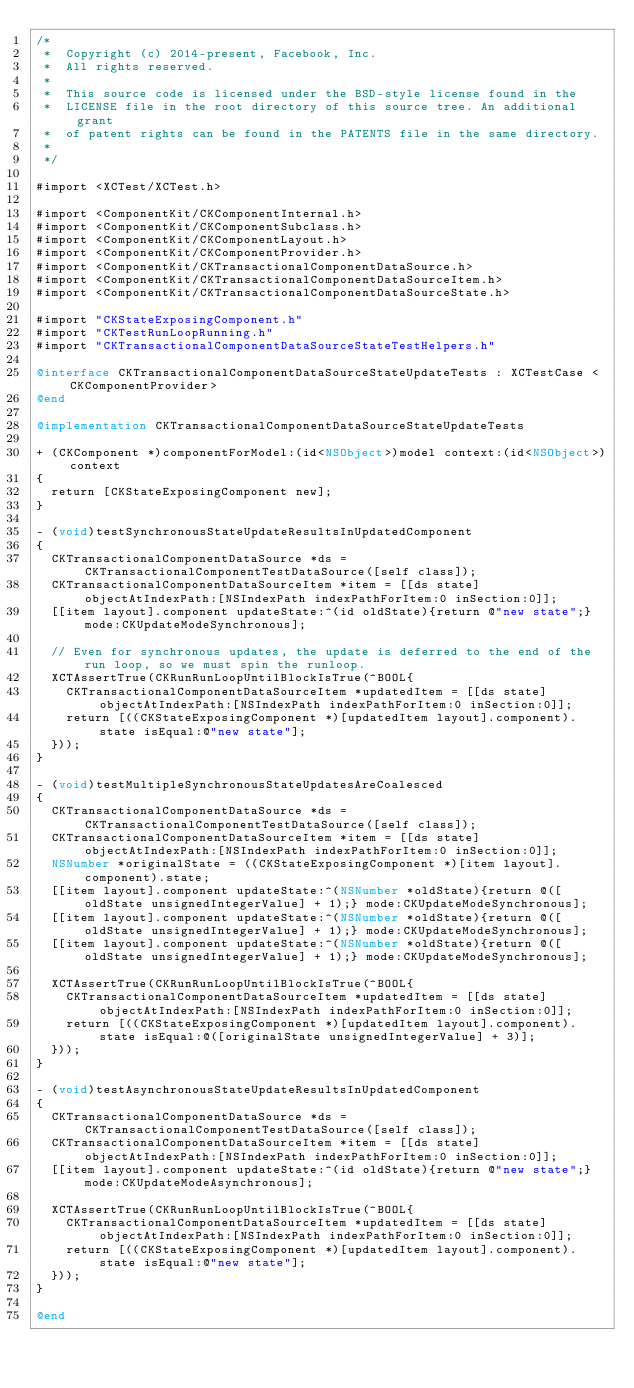<code> <loc_0><loc_0><loc_500><loc_500><_ObjectiveC_>/*
 *  Copyright (c) 2014-present, Facebook, Inc.
 *  All rights reserved.
 *
 *  This source code is licensed under the BSD-style license found in the
 *  LICENSE file in the root directory of this source tree. An additional grant
 *  of patent rights can be found in the PATENTS file in the same directory.
 *
 */

#import <XCTest/XCTest.h>

#import <ComponentKit/CKComponentInternal.h>
#import <ComponentKit/CKComponentSubclass.h>
#import <ComponentKit/CKComponentLayout.h>
#import <ComponentKit/CKComponentProvider.h>
#import <ComponentKit/CKTransactionalComponentDataSource.h>
#import <ComponentKit/CKTransactionalComponentDataSourceItem.h>
#import <ComponentKit/CKTransactionalComponentDataSourceState.h>

#import "CKStateExposingComponent.h"
#import "CKTestRunLoopRunning.h"
#import "CKTransactionalComponentDataSourceStateTestHelpers.h"

@interface CKTransactionalComponentDataSourceStateUpdateTests : XCTestCase <CKComponentProvider>
@end

@implementation CKTransactionalComponentDataSourceStateUpdateTests

+ (CKComponent *)componentForModel:(id<NSObject>)model context:(id<NSObject>)context
{
  return [CKStateExposingComponent new];
}

- (void)testSynchronousStateUpdateResultsInUpdatedComponent
{
  CKTransactionalComponentDataSource *ds = CKTransactionalComponentTestDataSource([self class]);
  CKTransactionalComponentDataSourceItem *item = [[ds state] objectAtIndexPath:[NSIndexPath indexPathForItem:0 inSection:0]];
  [[item layout].component updateState:^(id oldState){return @"new state";} mode:CKUpdateModeSynchronous];

  // Even for synchronous updates, the update is deferred to the end of the run loop, so we must spin the runloop.
  XCTAssertTrue(CKRunRunLoopUntilBlockIsTrue(^BOOL{
    CKTransactionalComponentDataSourceItem *updatedItem = [[ds state] objectAtIndexPath:[NSIndexPath indexPathForItem:0 inSection:0]];
    return [((CKStateExposingComponent *)[updatedItem layout].component).state isEqual:@"new state"];
  }));
}

- (void)testMultipleSynchronousStateUpdatesAreCoalesced
{
  CKTransactionalComponentDataSource *ds = CKTransactionalComponentTestDataSource([self class]);
  CKTransactionalComponentDataSourceItem *item = [[ds state] objectAtIndexPath:[NSIndexPath indexPathForItem:0 inSection:0]];
  NSNumber *originalState = ((CKStateExposingComponent *)[item layout].component).state;
  [[item layout].component updateState:^(NSNumber *oldState){return @([oldState unsignedIntegerValue] + 1);} mode:CKUpdateModeSynchronous];
  [[item layout].component updateState:^(NSNumber *oldState){return @([oldState unsignedIntegerValue] + 1);} mode:CKUpdateModeSynchronous];
  [[item layout].component updateState:^(NSNumber *oldState){return @([oldState unsignedIntegerValue] + 1);} mode:CKUpdateModeSynchronous];

  XCTAssertTrue(CKRunRunLoopUntilBlockIsTrue(^BOOL{
    CKTransactionalComponentDataSourceItem *updatedItem = [[ds state] objectAtIndexPath:[NSIndexPath indexPathForItem:0 inSection:0]];
    return [((CKStateExposingComponent *)[updatedItem layout].component).state isEqual:@([originalState unsignedIntegerValue] + 3)];
  }));
}

- (void)testAsynchronousStateUpdateResultsInUpdatedComponent
{
  CKTransactionalComponentDataSource *ds = CKTransactionalComponentTestDataSource([self class]);
  CKTransactionalComponentDataSourceItem *item = [[ds state] objectAtIndexPath:[NSIndexPath indexPathForItem:0 inSection:0]];
  [[item layout].component updateState:^(id oldState){return @"new state";} mode:CKUpdateModeAsynchronous];

  XCTAssertTrue(CKRunRunLoopUntilBlockIsTrue(^BOOL{
    CKTransactionalComponentDataSourceItem *updatedItem = [[ds state] objectAtIndexPath:[NSIndexPath indexPathForItem:0 inSection:0]];
    return [((CKStateExposingComponent *)[updatedItem layout].component).state isEqual:@"new state"];
  }));
}

@end
</code> 